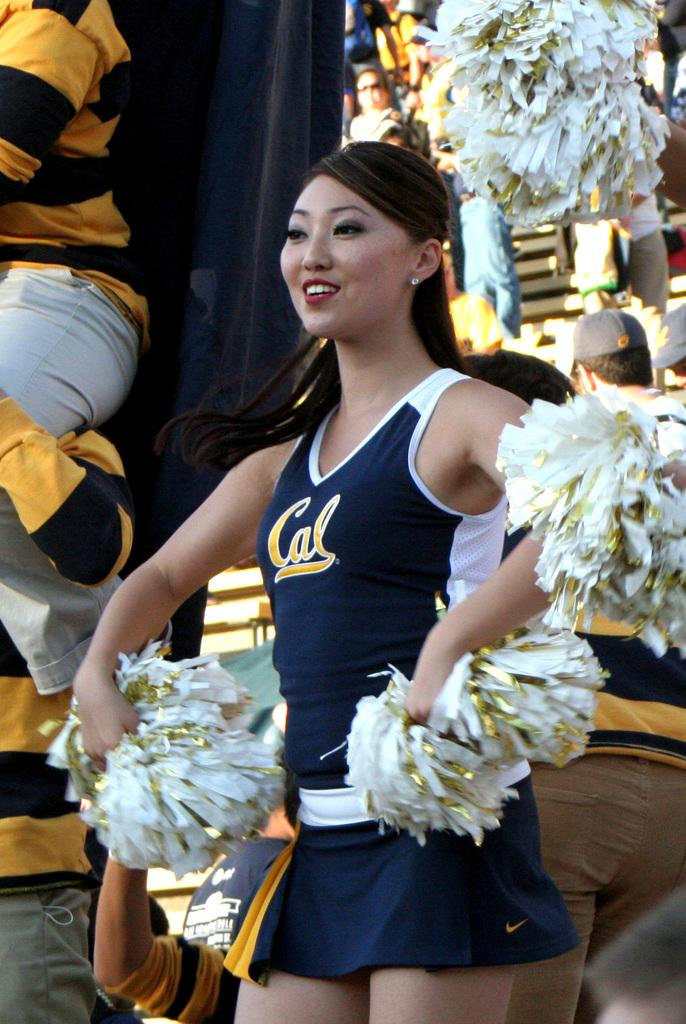<image>
Relay a brief, clear account of the picture shown. A cheerleader, representing Cal, cheers with her pom-poms. 